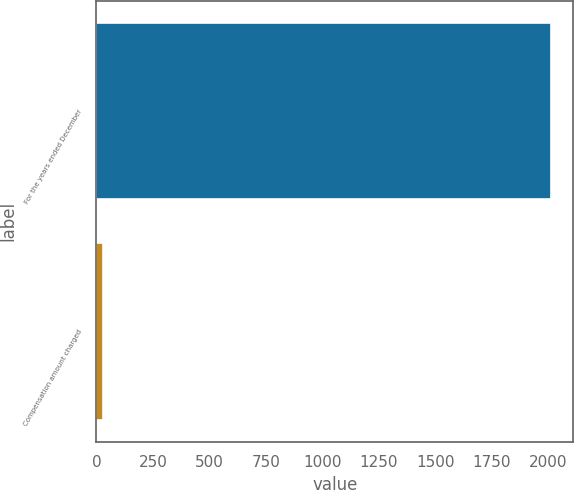Convert chart to OTSL. <chart><loc_0><loc_0><loc_500><loc_500><bar_chart><fcel>For the years ended December<fcel>Compensation amount charged<nl><fcel>2009<fcel>30<nl></chart> 